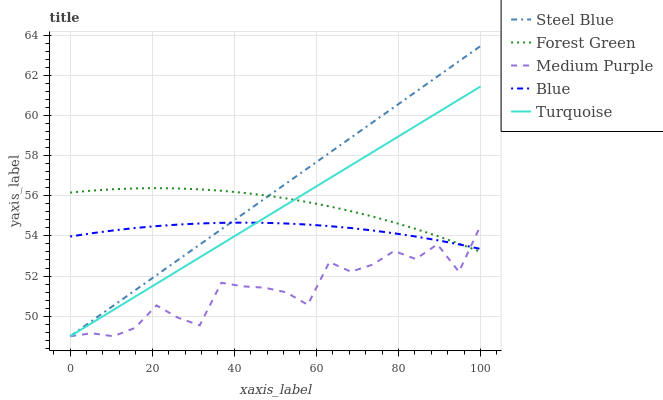Does Medium Purple have the minimum area under the curve?
Answer yes or no. Yes. Does Steel Blue have the maximum area under the curve?
Answer yes or no. Yes. Does Blue have the minimum area under the curve?
Answer yes or no. No. Does Blue have the maximum area under the curve?
Answer yes or no. No. Is Steel Blue the smoothest?
Answer yes or no. Yes. Is Medium Purple the roughest?
Answer yes or no. Yes. Is Blue the smoothest?
Answer yes or no. No. Is Blue the roughest?
Answer yes or no. No. Does Medium Purple have the lowest value?
Answer yes or no. Yes. Does Forest Green have the lowest value?
Answer yes or no. No. Does Steel Blue have the highest value?
Answer yes or no. Yes. Does Blue have the highest value?
Answer yes or no. No. Does Blue intersect Steel Blue?
Answer yes or no. Yes. Is Blue less than Steel Blue?
Answer yes or no. No. Is Blue greater than Steel Blue?
Answer yes or no. No. 